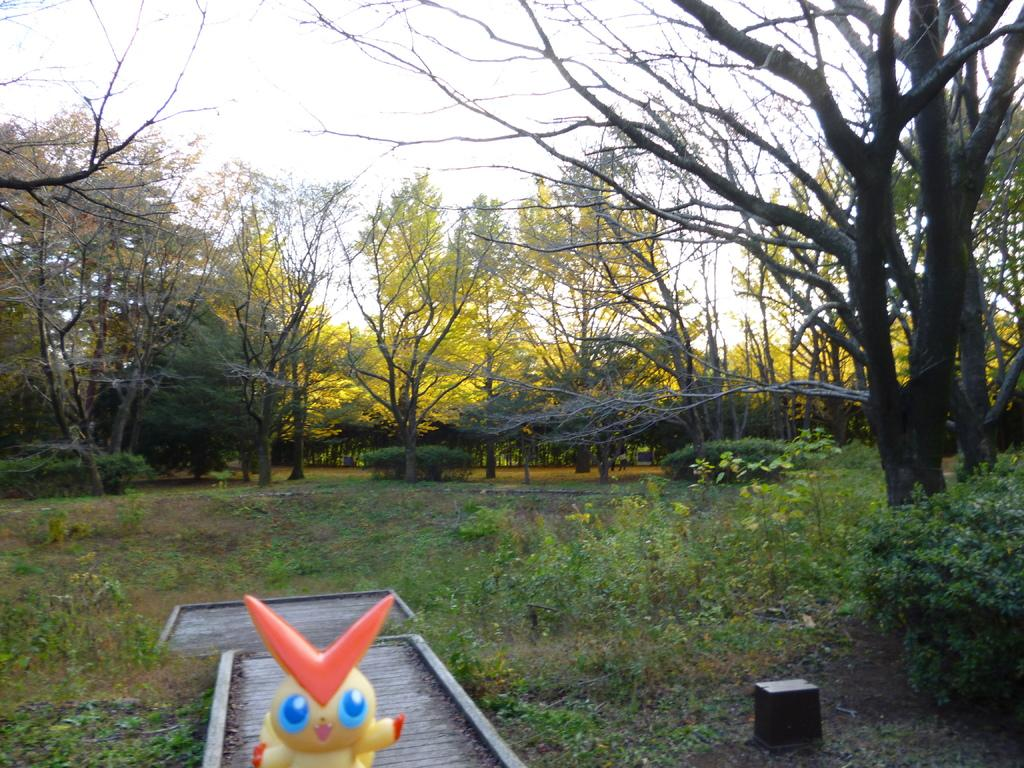What type of vegetation can be seen in the image? There is grass, plants, bushes, and trees in the image. What kind of pathway is present in the image? There is a walkway in the image. Is there any man-made structure visible in the image? Yes, there is a bridge in the image. What can be seen in the background of the image? The sky is visible in the background of the image. How many hooks are hanging from the trees in the image? There are no hooks hanging from the trees in the image. What type of fruit can be seen growing on the plants in the image? There is no fruit visible on the plants in the image. 